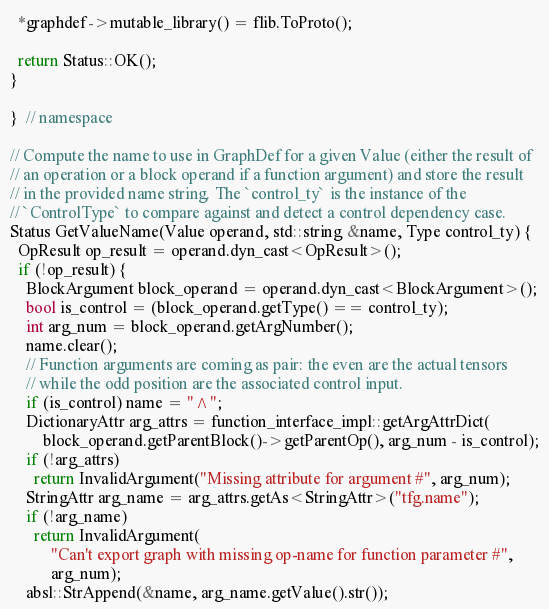<code> <loc_0><loc_0><loc_500><loc_500><_C++_>  *graphdef->mutable_library() = flib.ToProto();

  return Status::OK();
}

}  // namespace

// Compute the name to use in GraphDef for a given Value (either the result of
// an operation or a block operand if a function argument) and store the result
// in the provided name string. The `control_ty` is the instance of the
// `ControlType` to compare against and detect a control dependency case.
Status GetValueName(Value operand, std::string &name, Type control_ty) {
  OpResult op_result = operand.dyn_cast<OpResult>();
  if (!op_result) {
    BlockArgument block_operand = operand.dyn_cast<BlockArgument>();
    bool is_control = (block_operand.getType() == control_ty);
    int arg_num = block_operand.getArgNumber();
    name.clear();
    // Function arguments are coming as pair: the even are the actual tensors
    // while the odd position are the associated control input.
    if (is_control) name = "^";
    DictionaryAttr arg_attrs = function_interface_impl::getArgAttrDict(
        block_operand.getParentBlock()->getParentOp(), arg_num - is_control);
    if (!arg_attrs)
      return InvalidArgument("Missing attribute for argument #", arg_num);
    StringAttr arg_name = arg_attrs.getAs<StringAttr>("tfg.name");
    if (!arg_name)
      return InvalidArgument(
          "Can't export graph with missing op-name for function parameter #",
          arg_num);
    absl::StrAppend(&name, arg_name.getValue().str());</code> 